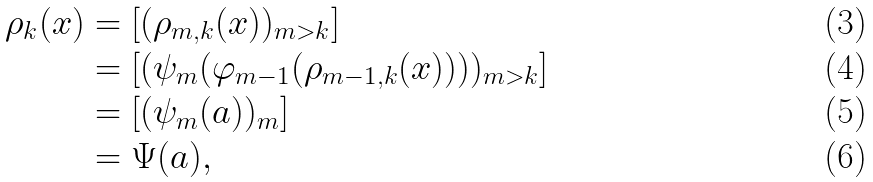Convert formula to latex. <formula><loc_0><loc_0><loc_500><loc_500>\rho _ { k } ( x ) & = [ ( \rho _ { m , k } ( x ) ) _ { m > k } ] \\ & = [ ( \psi _ { m } ( \varphi _ { m - 1 } ( \rho _ { m - 1 , k } ( x ) ) ) ) _ { m > k } ] \\ & = [ ( \psi _ { m } ( a ) ) _ { m } ] \\ & = \Psi ( a ) ,</formula> 